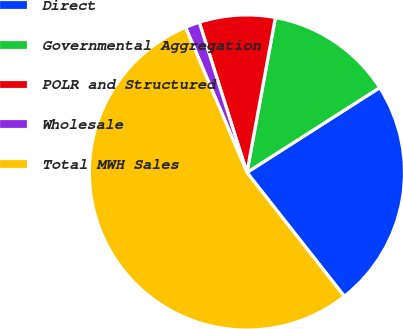Convert chart to OTSL. <chart><loc_0><loc_0><loc_500><loc_500><pie_chart><fcel>Direct<fcel>Governmental Aggregation<fcel>POLR and Structured<fcel>Wholesale<fcel>Total MWH Sales<nl><fcel>23.44%<fcel>13.06%<fcel>7.78%<fcel>1.48%<fcel>54.24%<nl></chart> 